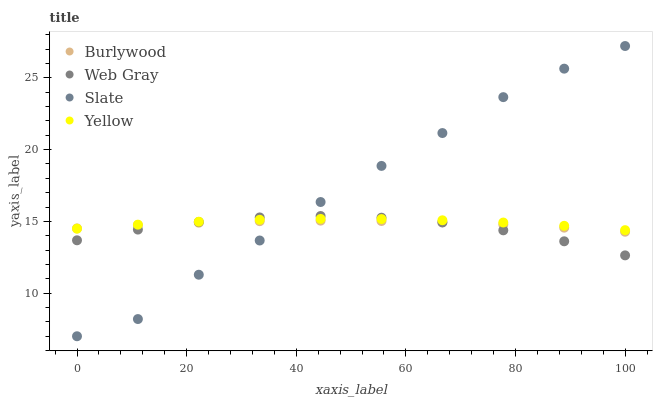Does Web Gray have the minimum area under the curve?
Answer yes or no. Yes. Does Slate have the maximum area under the curve?
Answer yes or no. Yes. Does Slate have the minimum area under the curve?
Answer yes or no. No. Does Web Gray have the maximum area under the curve?
Answer yes or no. No. Is Burlywood the smoothest?
Answer yes or no. Yes. Is Slate the roughest?
Answer yes or no. Yes. Is Web Gray the smoothest?
Answer yes or no. No. Is Web Gray the roughest?
Answer yes or no. No. Does Slate have the lowest value?
Answer yes or no. Yes. Does Web Gray have the lowest value?
Answer yes or no. No. Does Slate have the highest value?
Answer yes or no. Yes. Does Web Gray have the highest value?
Answer yes or no. No. Does Web Gray intersect Burlywood?
Answer yes or no. Yes. Is Web Gray less than Burlywood?
Answer yes or no. No. Is Web Gray greater than Burlywood?
Answer yes or no. No. 